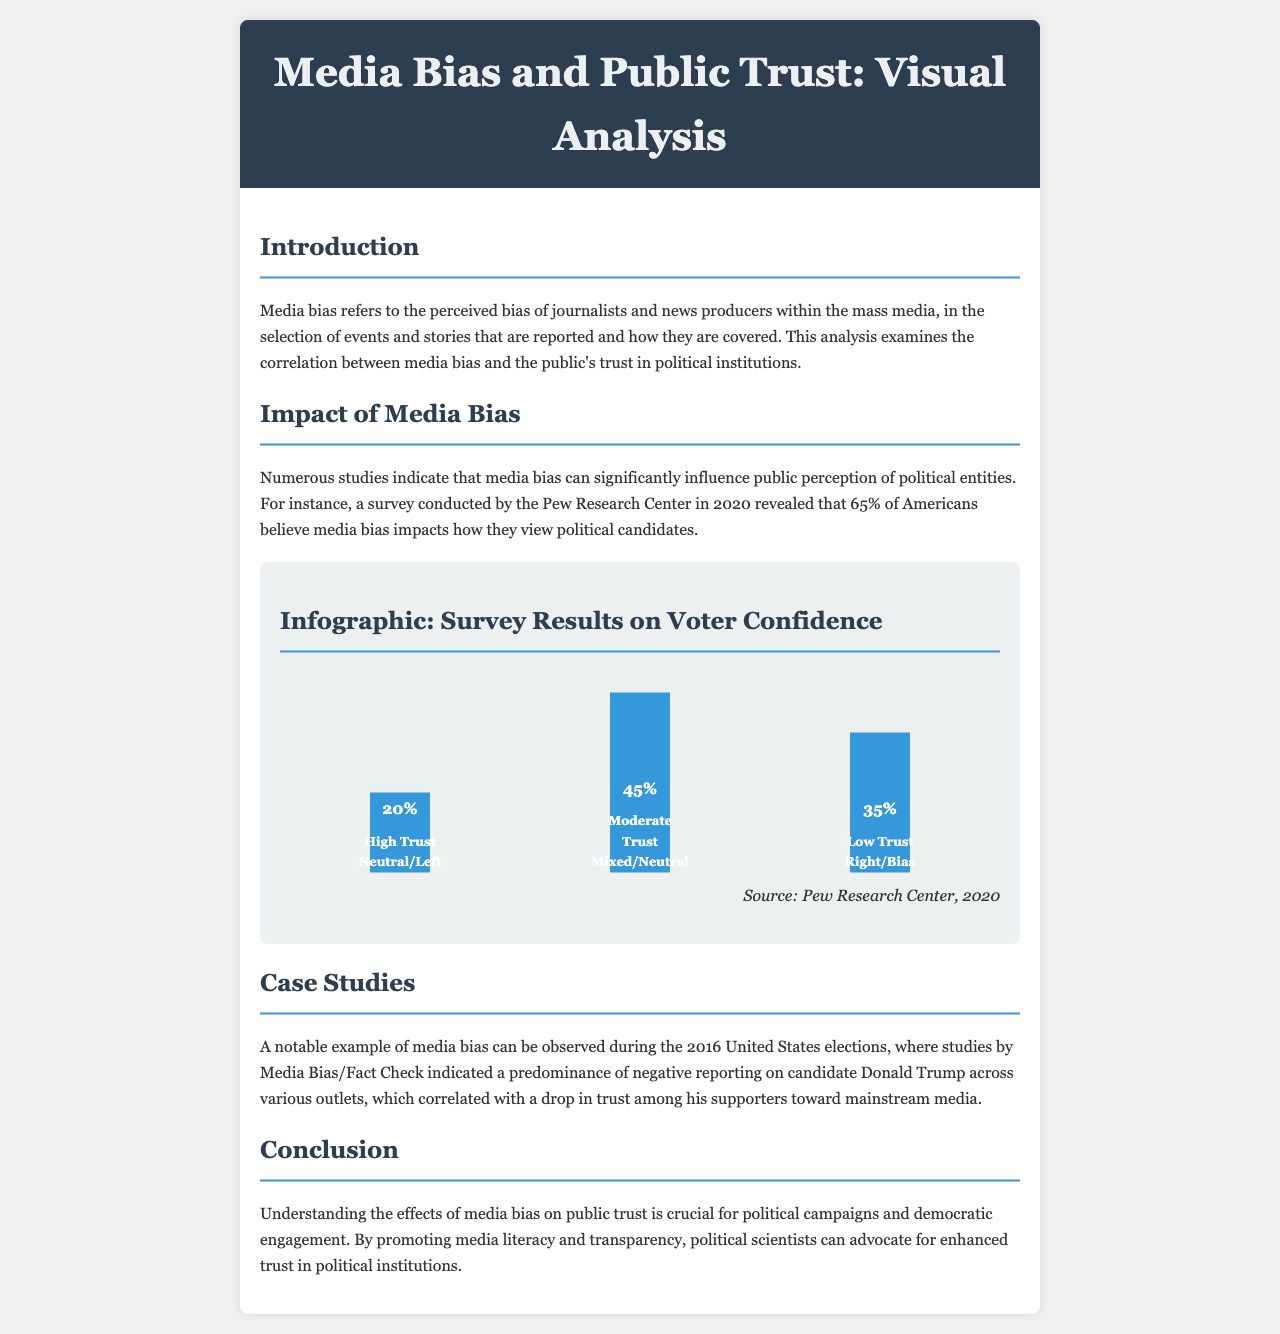What is the title of the brochure? The title of the brochure is stated in the header section of the document.
Answer: Media Bias and Public Trust: Visual Analysis What percentage of Americans believes media bias impacts their view of political candidates? The specific percentage is mentioned in the section about the impact of media bias.
Answer: 65% What proportion of respondents reported having high trust in political institutions according to the infographic? The infographic indicates the percentage of respondents with high trust, represented by a bar.
Answer: 20% Which political alignment corresponds to the low trust level in the infographic? The infographic provides labels for different trust levels and their corresponding alignments.
Answer: Right/Bias What is the source of the survey results presented in the infographic? The source is indicated below the infographic, attributed to a recognized research center.
Answer: Pew Research Center, 2020 What was a notable example of media bias discussed in the brochure? The brochure gives a specific historical example to illustrate media bias effects on public perception.
Answer: 2016 United States elections What is suggested as a way to promote trust in political institutions? The brochure concludes with a suggestion on how to enhance public trust in politics.
Answer: Media literacy and transparency 